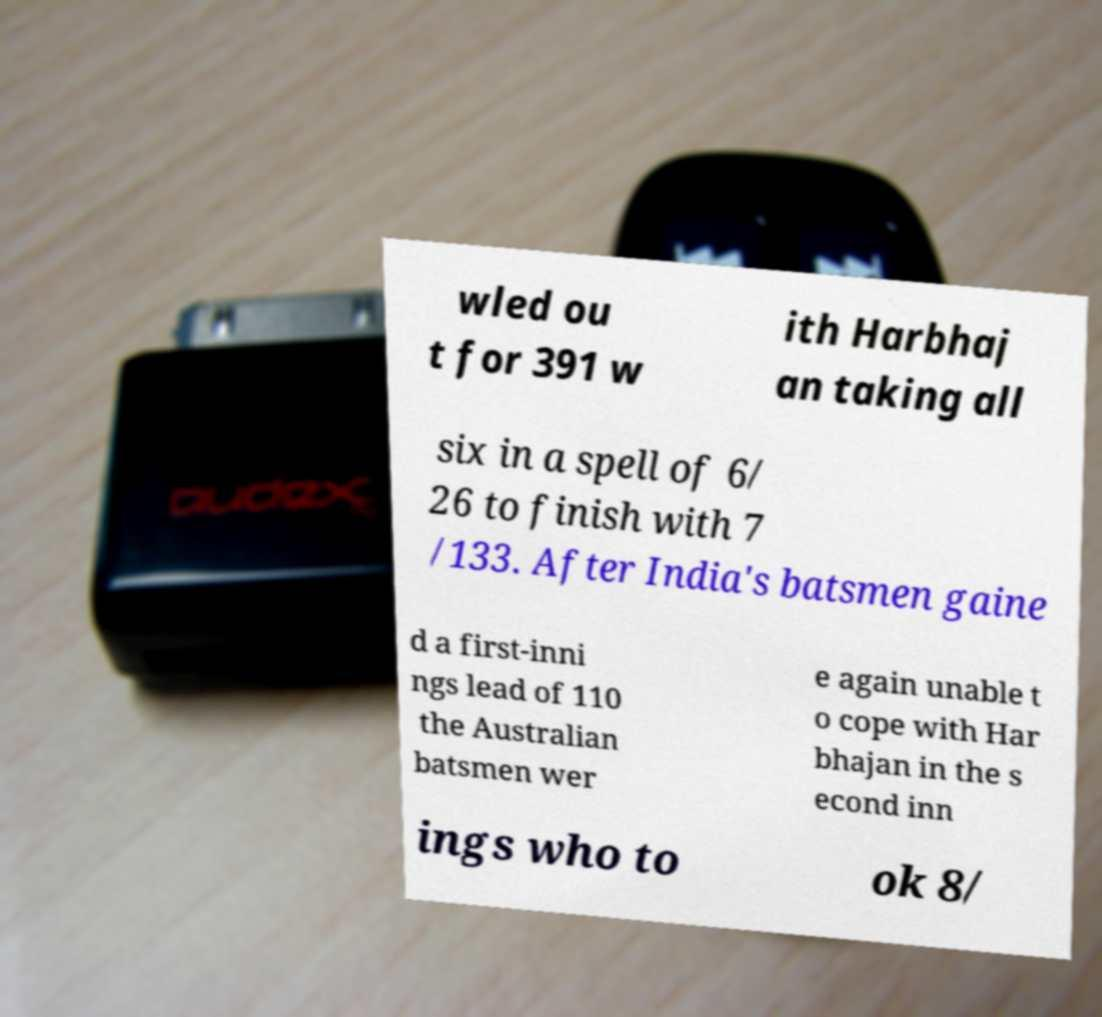Could you extract and type out the text from this image? wled ou t for 391 w ith Harbhaj an taking all six in a spell of 6/ 26 to finish with 7 /133. After India's batsmen gaine d a first-inni ngs lead of 110 the Australian batsmen wer e again unable t o cope with Har bhajan in the s econd inn ings who to ok 8/ 